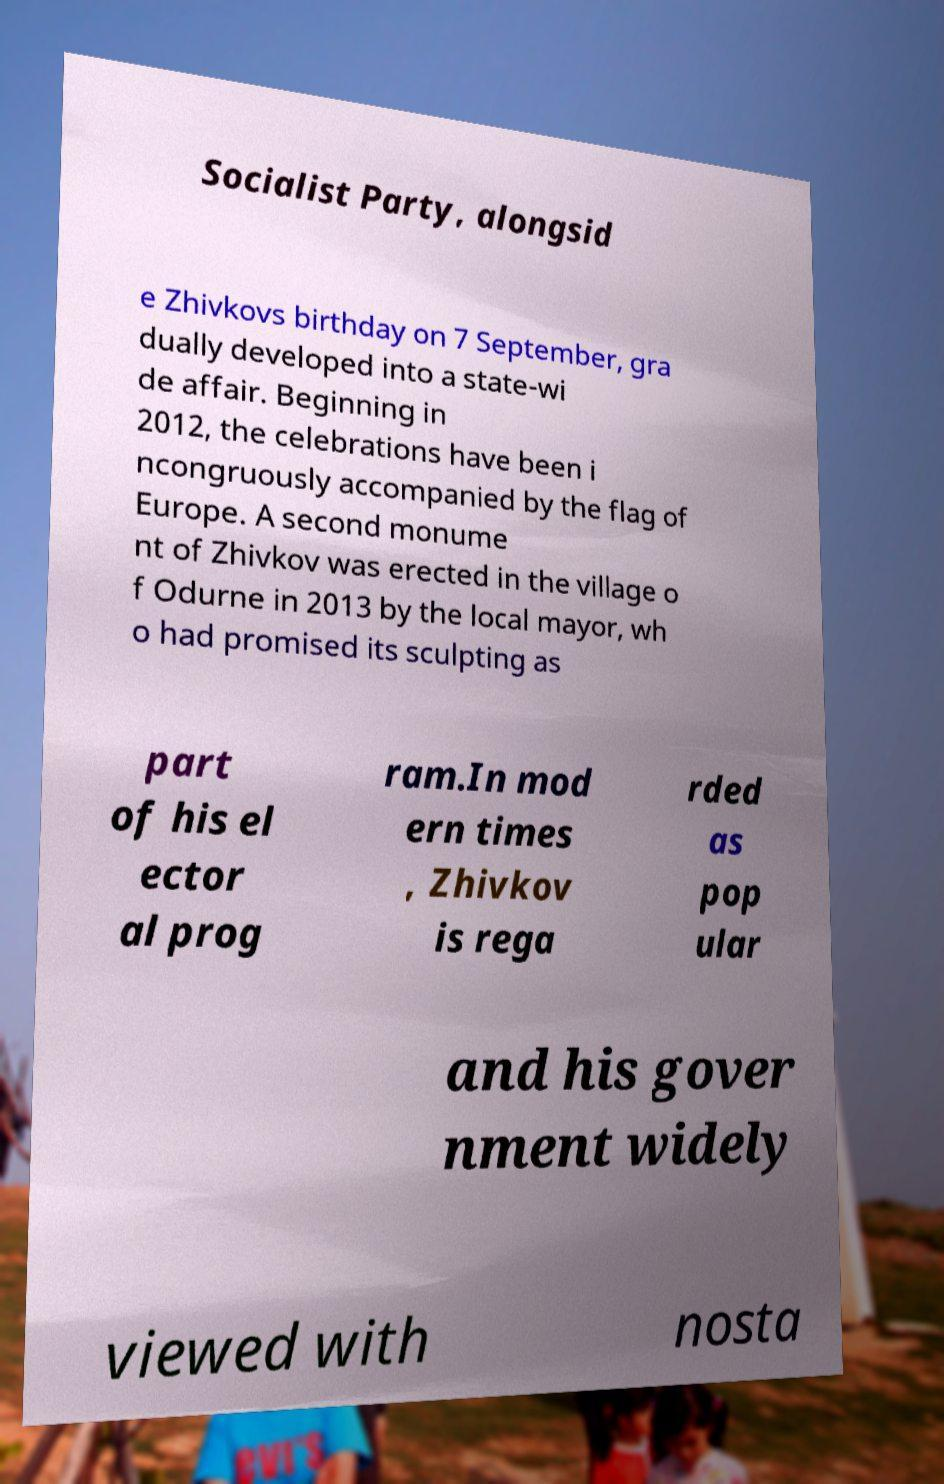I need the written content from this picture converted into text. Can you do that? Socialist Party, alongsid e Zhivkovs birthday on 7 September, gra dually developed into a state-wi de affair. Beginning in 2012, the celebrations have been i ncongruously accompanied by the flag of Europe. A second monume nt of Zhivkov was erected in the village o f Odurne in 2013 by the local mayor, wh o had promised its sculpting as part of his el ector al prog ram.In mod ern times , Zhivkov is rega rded as pop ular and his gover nment widely viewed with nosta 